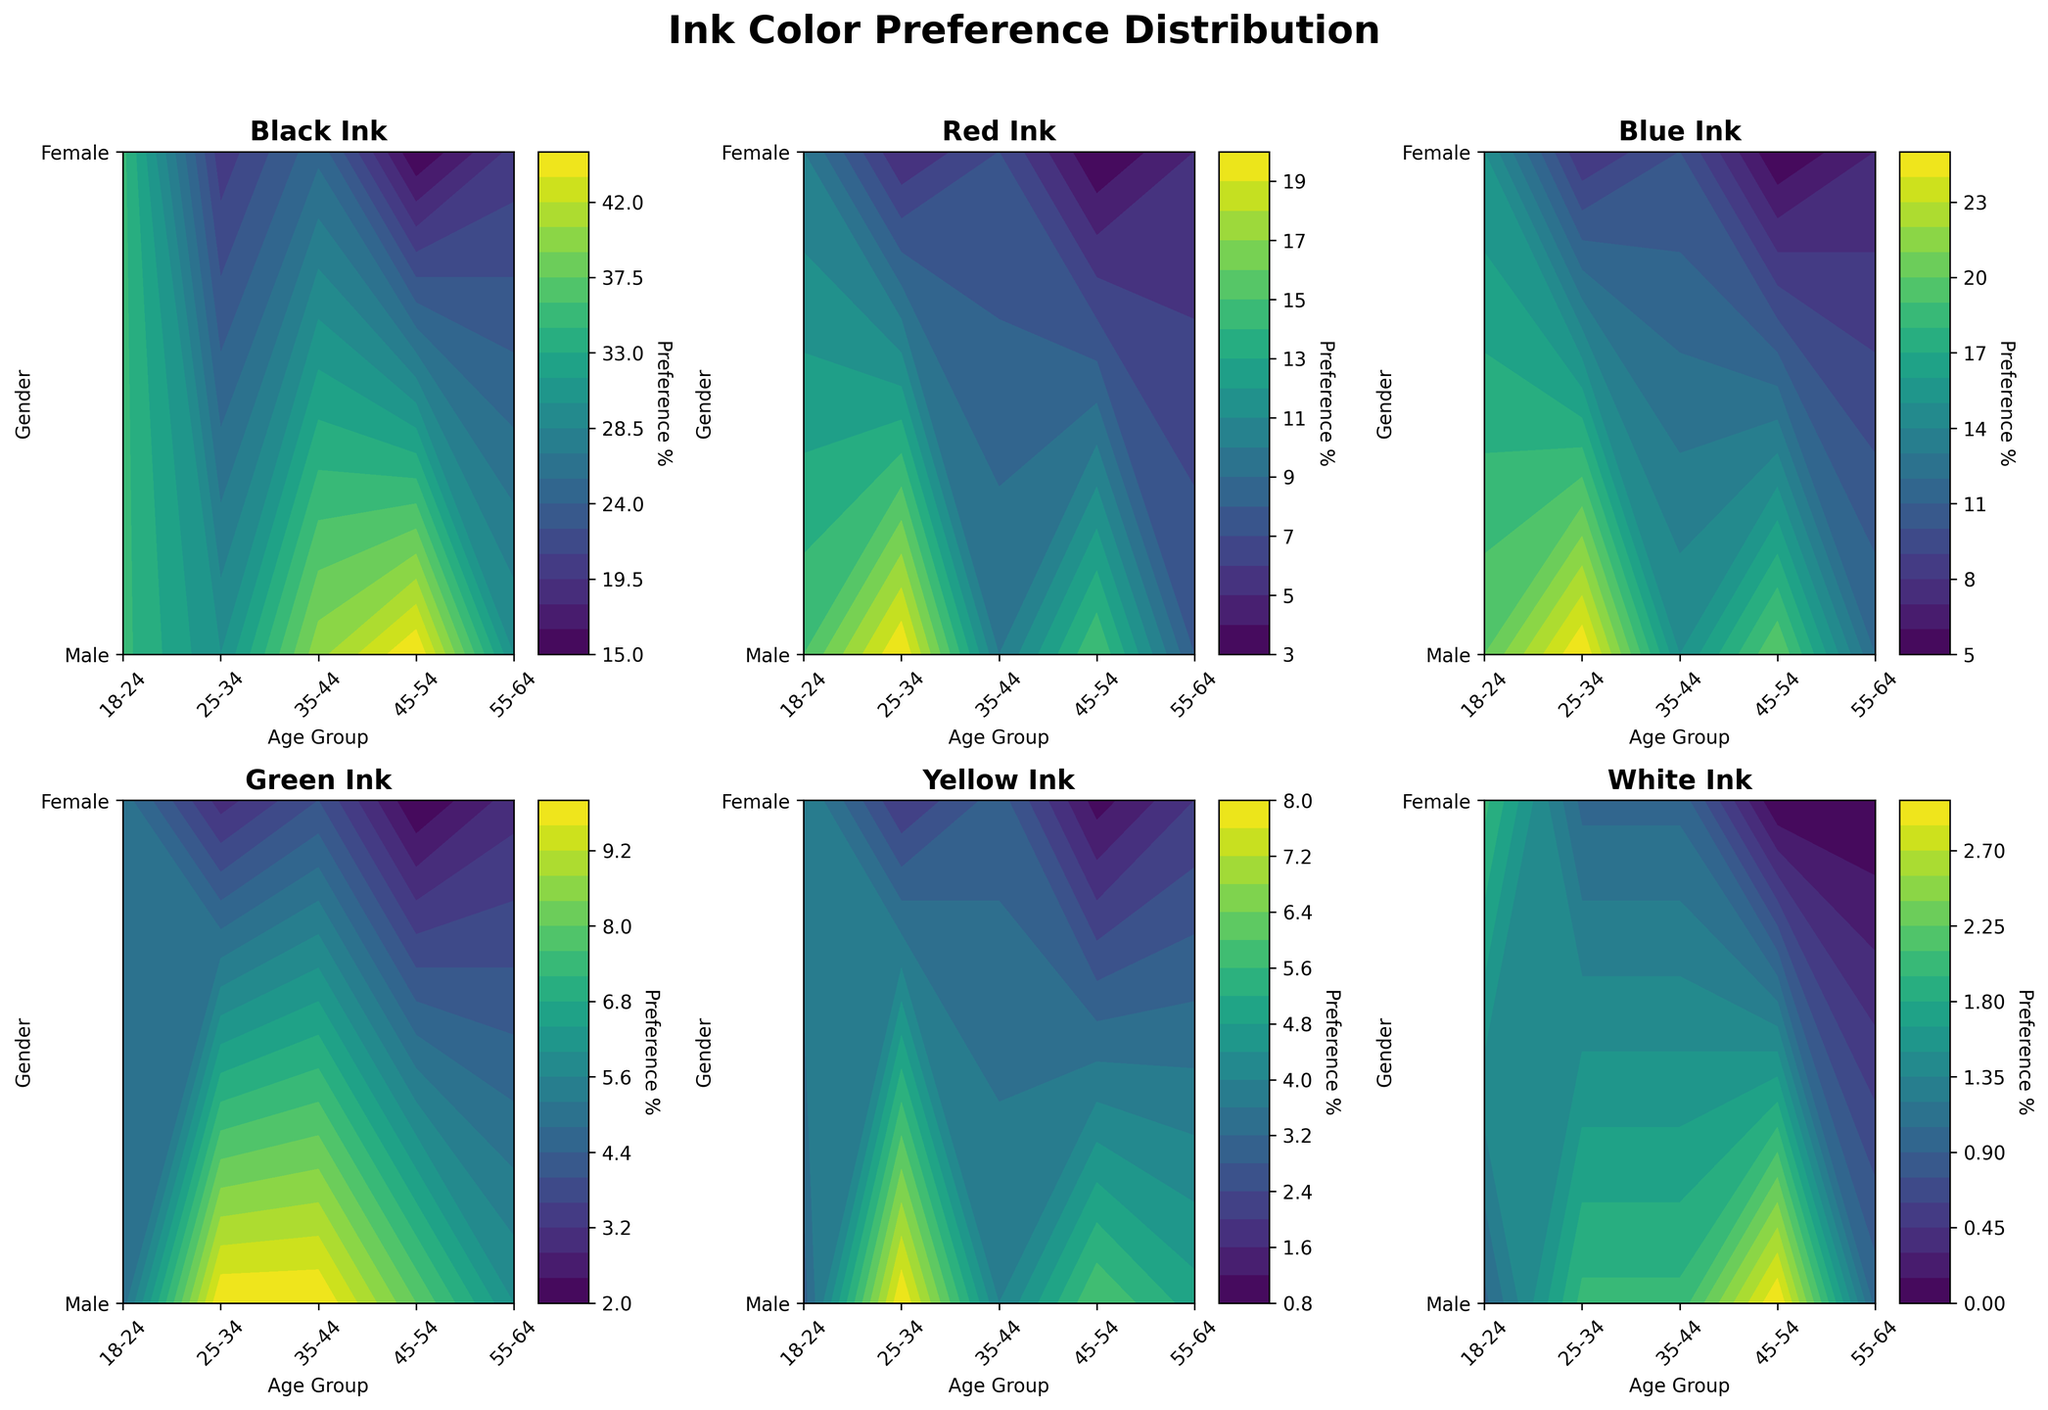What's the title of the figure? The title is mentioned at the top of the plot.
Answer: Ink Color Preference Distribution Which gender prefers black ink the most? By analyzing the darker contours, we see that females in the 25-34 age group show the highest preference for black ink.
Answer: Female (25-34) For which age group and gender is the preference for red ink the lowest? The lightest contour for red in the figure corresponds to males in the 55-64 age group.
Answer: Male (55-64) What is the difference in blue ink preference between males aged 18-24 and females aged 35-44? The contour for blue ink shows 20 for males aged 18-24 and 15 for females aged 35-44. The difference is 20 - 15 = 5.
Answer: 5 Compare the preference for green ink between males and females in the 45-54 age group. The contours for green ink show 3 for males and 4 for females in the 45-54 age group.
Answer: Female (4) > Male (3) Which age group has the highest overall preference for yellow ink? The darkest contour for yellow ink is in the 18-24 age group for females.
Answer: 18-24 (Female) Which ink color shows the most consistent preference across all age groups and genders? By looking at the contours, white ink shows very low variation across different demographics.
Answer: White What's the general trend in black ink preference as age increases? The contours for black ink show a decreasing trend in preference as the age groups move from younger (18-24) to older (55-64).
Answer: Decreases How does the preference for blue ink in females compare between the 18-24 and 25-34 age groups? The contours for blue ink show a higher preference in the 18-24 age group (25) compared to the 25-34 age group (20).
Answer: 18-24 > 25-34 What is the average preference for green ink among all age groups for males? The contours for green ink show preferences as 5, 10, 6, 3, 2 for males across the age groups 18-24, 25-34, 35-44, 45-54, 55-64. The average is (5 + 10 + 6 + 3 + 2) / 5 = 5.2.
Answer: 5.2 